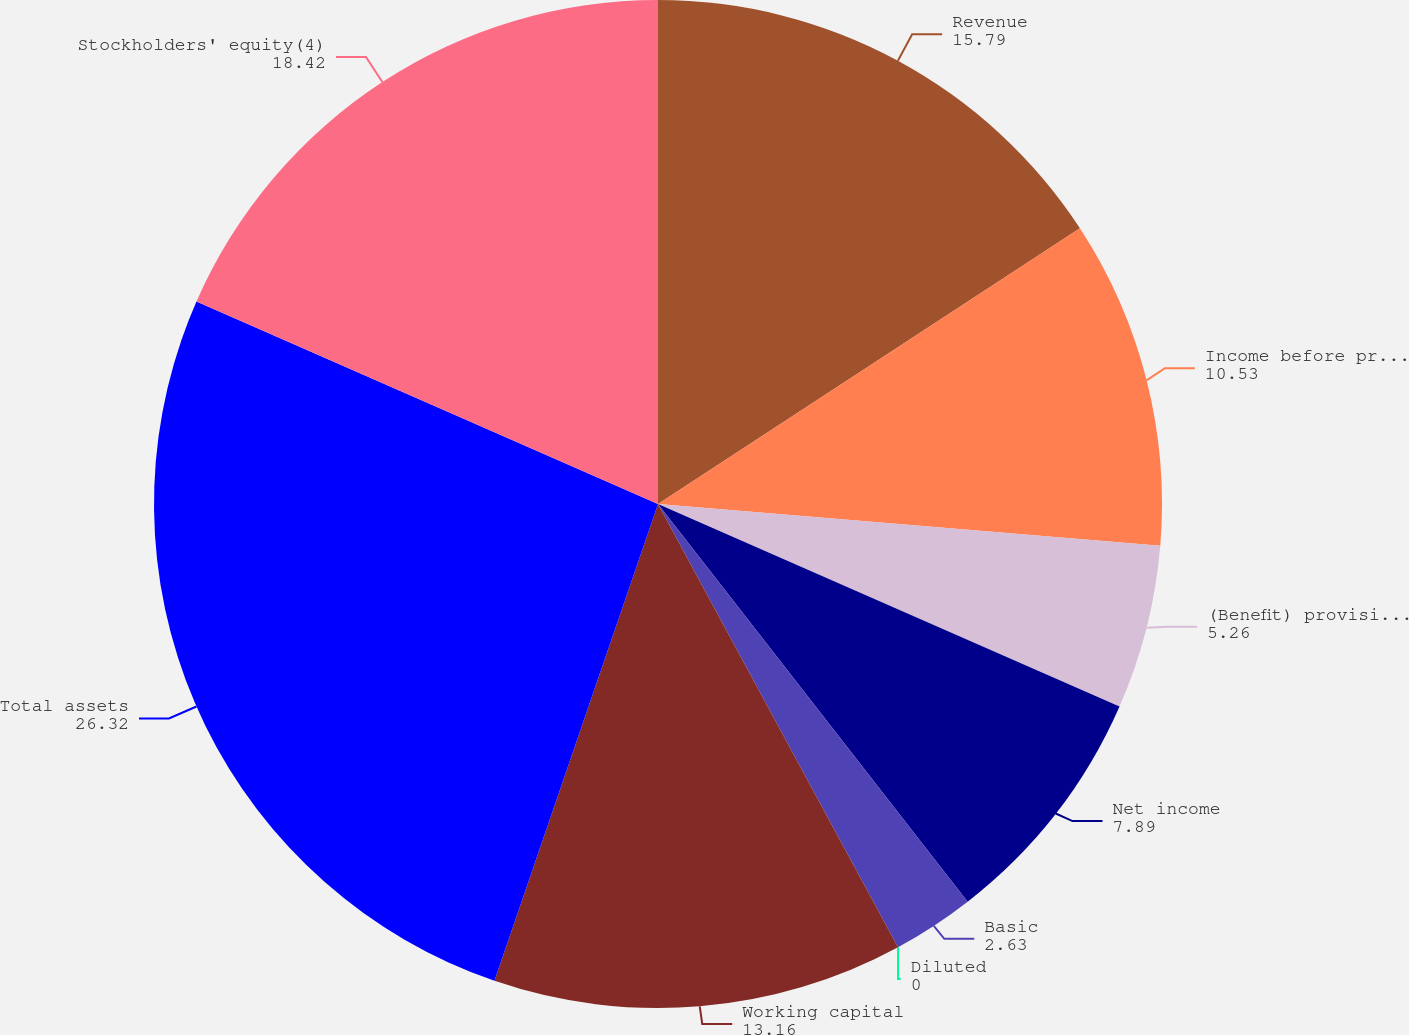Convert chart to OTSL. <chart><loc_0><loc_0><loc_500><loc_500><pie_chart><fcel>Revenue<fcel>Income before provisions for<fcel>(Benefit) provision for income<fcel>Net income<fcel>Basic<fcel>Diluted<fcel>Working capital<fcel>Total assets<fcel>Stockholders' equity(4)<nl><fcel>15.79%<fcel>10.53%<fcel>5.26%<fcel>7.89%<fcel>2.63%<fcel>0.0%<fcel>13.16%<fcel>26.32%<fcel>18.42%<nl></chart> 